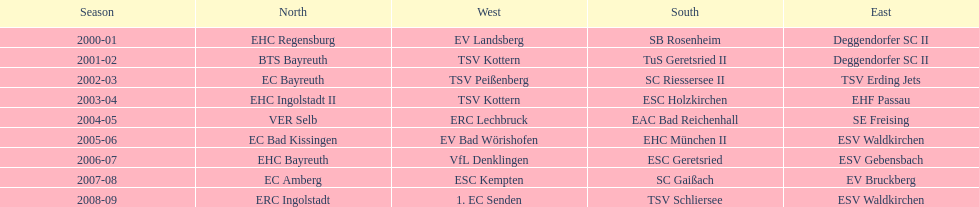What is the number of seasons covered in the table? 9. 